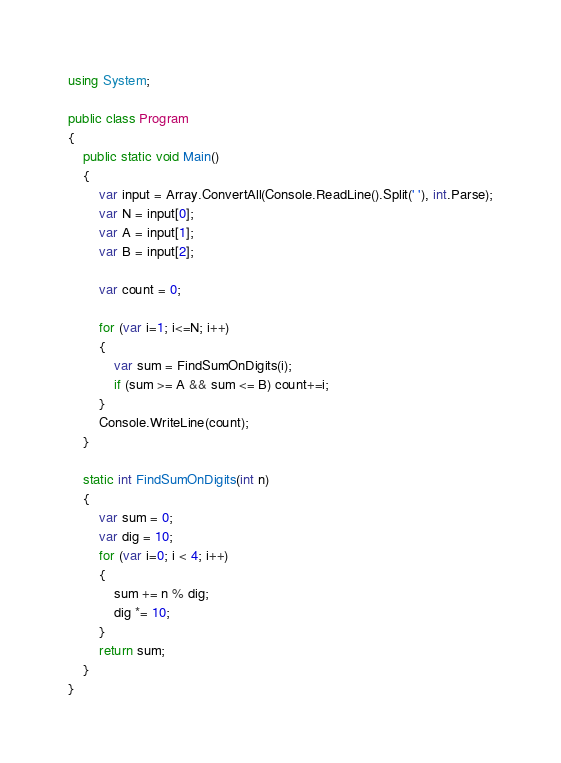<code> <loc_0><loc_0><loc_500><loc_500><_C#_>using System;

public class Program
{
    public static void Main()
	{
        var input = Array.ConvertAll(Console.ReadLine().Split(' '), int.Parse);
        var N = input[0];
        var A = input[1];
        var B = input[2];

        var count = 0;

        for (var i=1; i<=N; i++)
        {
            var sum = FindSumOnDigits(i);
            if (sum >= A && sum <= B) count+=i;
        }
        Console.WriteLine(count);
    }

    static int FindSumOnDigits(int n)
    {
        var sum = 0;
        var dig = 10;
        for (var i=0; i < 4; i++)
        {
            sum += n % dig;
            dig *= 10;
        }
        return sum;
    }
}
</code> 